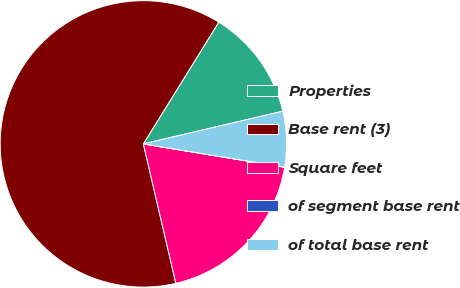Convert chart. <chart><loc_0><loc_0><loc_500><loc_500><pie_chart><fcel>Properties<fcel>Base rent (3)<fcel>Square feet<fcel>of segment base rent<fcel>of total base rent<nl><fcel>12.51%<fcel>62.47%<fcel>18.75%<fcel>0.01%<fcel>6.26%<nl></chart> 